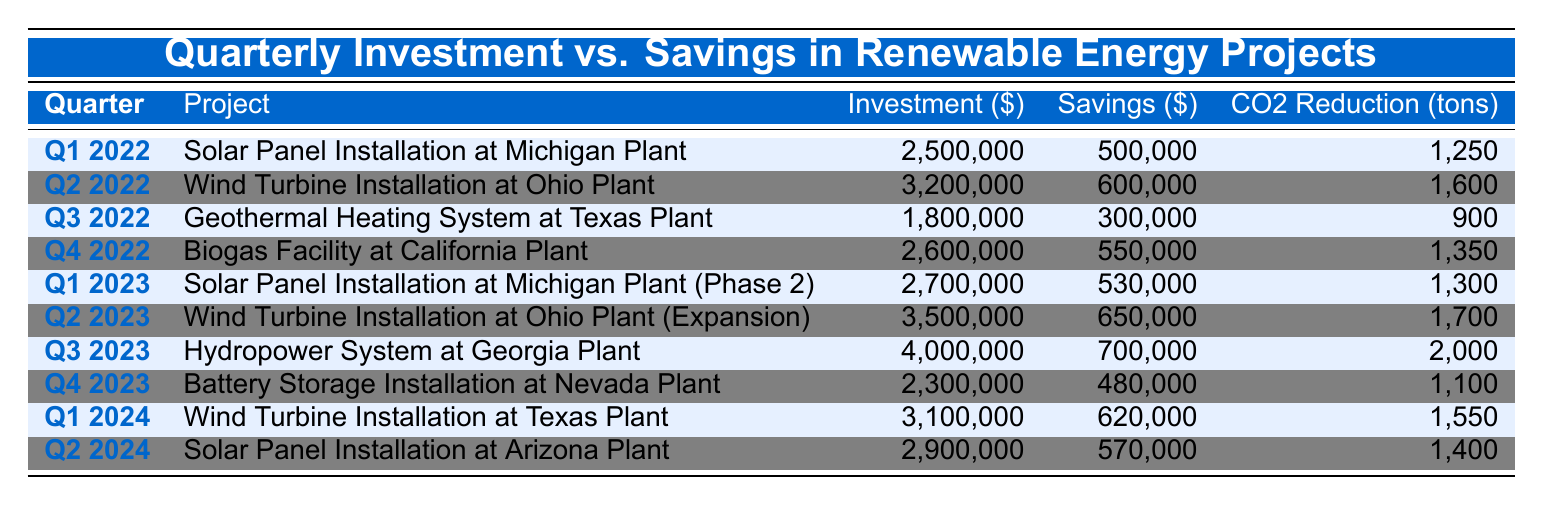What was the investment for the Wind Turbine Installation at Ohio Plant in Q2 2022? The table specifies that the project "Wind Turbine Installation at Ohio Plant" occurred in Q2 2022 with an investment value listed as 3,200,000.
Answer: 3,200,000 What is the total savings generated from the Biogas Facility at California Plant and the Hydropower System at Georgia Plant? The savings for the Biogas Facility at California Plant is 550,000 and for the Hydropower System at Georgia Plant is 700,000. Adding them together gives 550,000 + 700,000 = 1,250,000.
Answer: 1,250,000 Did the investment for the Solar Panel Installation at Michigan Plant (Phase 2) exceed the investment for the Geothermal Heating System at Texas Plant? The investment for the Solar Panel Installation at Michigan Plant (Phase 2) is 2,700,000, while the investment for the Geothermal Heating System at Texas Plant is 1,800,000. Since 2,700,000 is greater than 1,800,000, the statement is true.
Answer: Yes What was the average CO2 reduction from all the projects listed in Q1 2022 and Q1 2023? The CO2 reductions for Q1 2022 and Q1 2023 are 1,250 tons and 1,300 tons respectively. The average is calculated by summing these values (1,250 + 1,300) and dividing by 2, which results in 2,550 divided by 2, giving 1,275 tons.
Answer: 1,275 Which project had the highest savings in Q3 2023? In Q3 2023, the project listed is "Hydropower System at Georgia Plant" with savings of 700,000, which is the only project listed in that quarter. Therefore, it can be considered the highest savings by default for that period.
Answer: Hydropower System at Georgia Plant What was the difference in investment between the Wind Turbine Installation at Texas Plant in Q1 2024 and the Solar Panel Installation at Arizona Plant in Q2 2024? The investment for the Wind Turbine Installation at Texas Plant is 3,100,000 and for the Solar Panel Installation at Arizona Plant, it is 2,900,000. The difference is calculated as 3,100,000 - 2,900,000 = 200,000.
Answer: 200,000 Are there any projects listed with savings greater than 600,000? The projects with savings greater than 600,000 are "Wind Turbine Installation at Ohio Plant" with 600,000, "Wind Turbine Installation at Ohio Plant (Expansion)" with 650,000, and "Hydropower System at Georgia Plant" with 700,000. Since there are projects meeting this criteria, the answer is yes.
Answer: Yes What is the total CO2 reduction across all projects in Q2 2022 and Q2 2023? The CO2 reductions for Q2 2022 and Q2 2023 are 1,600 tons and 1,700 tons respectively. The total is obtained by summing these values: 1,600 + 1,700 = 3,300 tons.
Answer: 3,300 Which project from Q4 2023 had the lowest investment? In Q4 2023, "Battery Storage Installation at Nevada Plant" is reported with an investment of 2,300,000. However, this is the only project listed for that quarter, making it the lowest by default.
Answer: Battery Storage Installation at Nevada Plant 